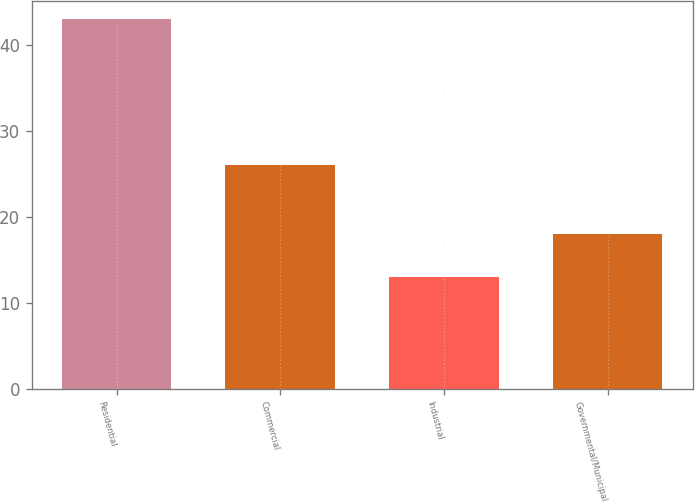Convert chart to OTSL. <chart><loc_0><loc_0><loc_500><loc_500><bar_chart><fcel>Residential<fcel>Commercial<fcel>Industrial<fcel>Governmental/Municipal<nl><fcel>43<fcel>26<fcel>13<fcel>18<nl></chart> 